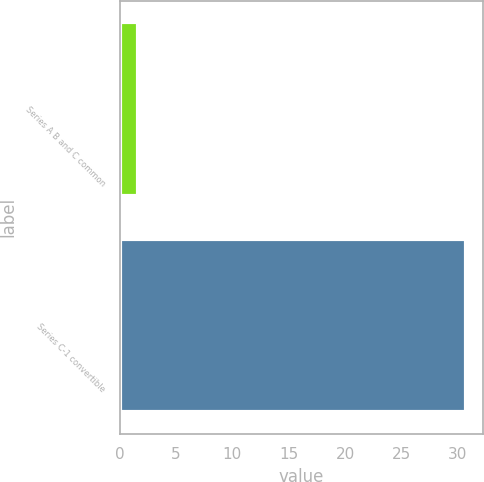Convert chart to OTSL. <chart><loc_0><loc_0><loc_500><loc_500><bar_chart><fcel>Series A B and C common<fcel>Series C-1 convertible<nl><fcel>1.59<fcel>30.74<nl></chart> 